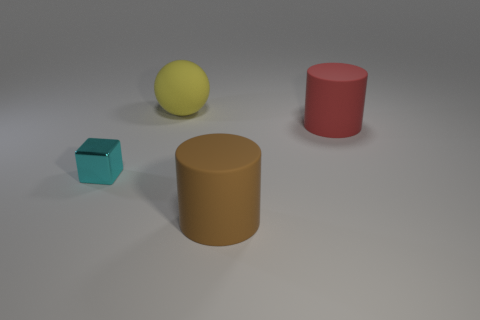What can you infer about the material of the objects? Based on the visual cues, the turquoise cube seems to have a slightly glossy texture, indicative of a smooth plastic or polished stone. The ochre and red cylinders appear to have a matte finish, which could suggest a rough texture like cardboard or unglazed ceramic. The yellow sphere has a matte finish too, which could imply a rubbery texture. Do the objects seem to be in any particular arrangement? The objects are placed in a seemingly deliberate configuration with ample space between them, suggesting a structured arrangement. Each object is positioned distinctly apart from the others, which gives the scene a sense of order and intention, possibly for an instructional purpose or a visual study of forms and colors. 